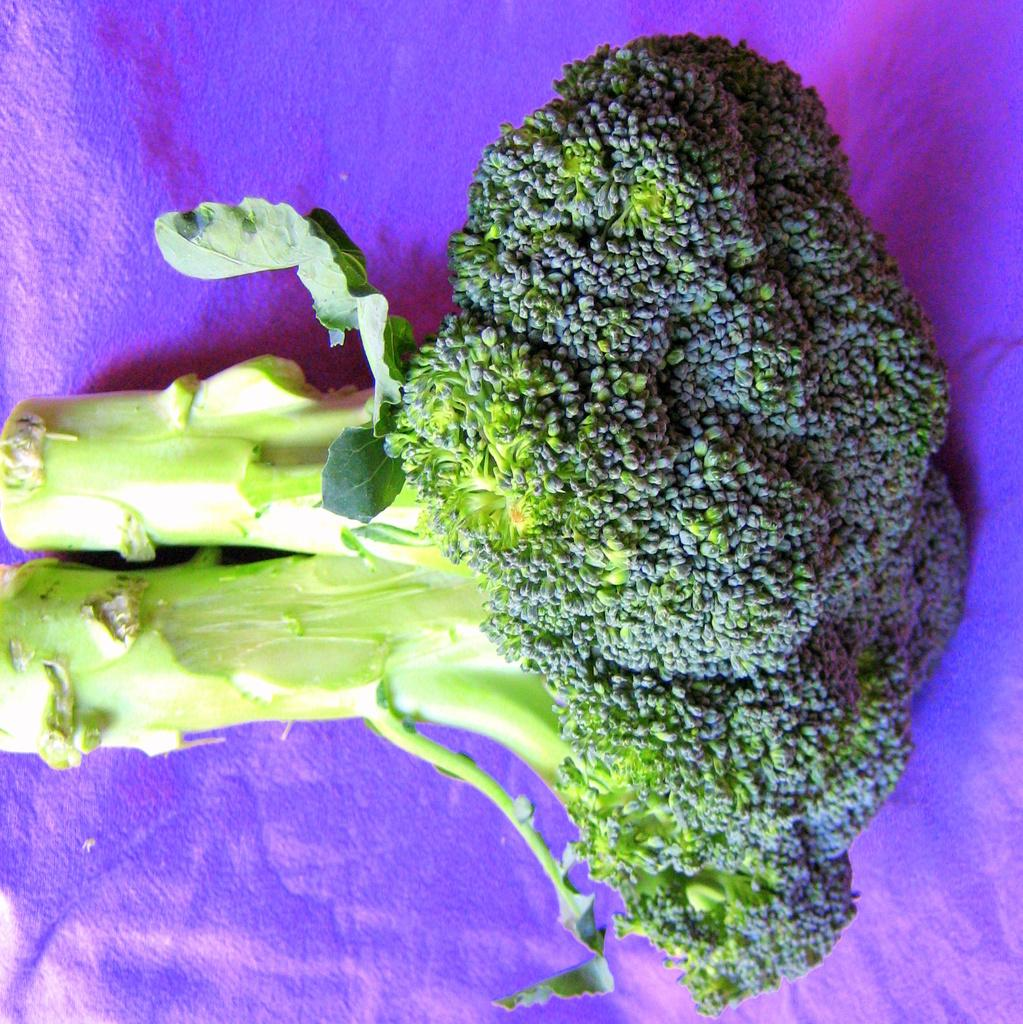What color are the vegetables in the image? The vegetables in the image are green. What color is the object on which the vegetables are placed? The object is purple. How are the green vegetables arranged in the image? The green vegetables are placed on the purple object. What type of straw is being used by the mother in the image? There is no mother or straw present in the image. How many grapes are visible on the purple object in the image? There are no grapes visible in the image; only green vegetables are present. 